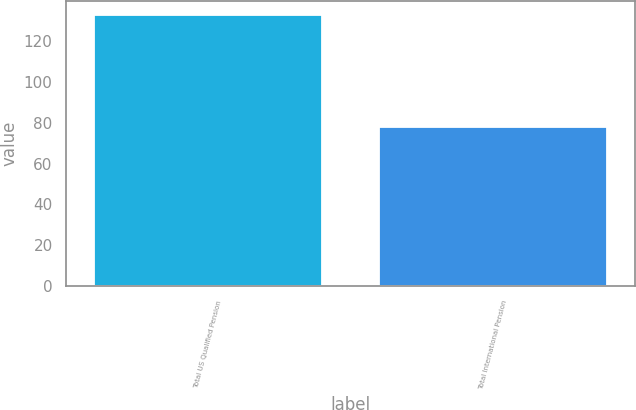Convert chart to OTSL. <chart><loc_0><loc_0><loc_500><loc_500><bar_chart><fcel>Total US Qualified Pension<fcel>Total International Pension<nl><fcel>132.8<fcel>77.7<nl></chart> 